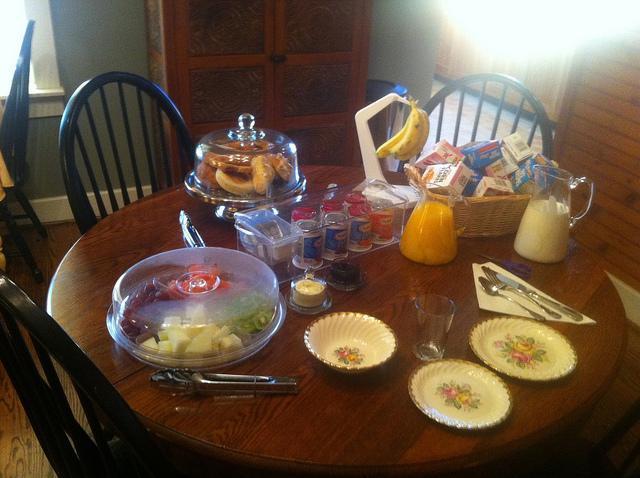How many plates are on the table?
Give a very brief answer. 3. How many chairs are visible?
Give a very brief answer. 5. How many bowls are there?
Give a very brief answer. 2. How many cups are visible?
Give a very brief answer. 2. 